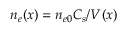Convert formula to latex. <formula><loc_0><loc_0><loc_500><loc_500>n _ { e } ( x ) = n _ { e 0 } C _ { s } / V ( x )</formula> 